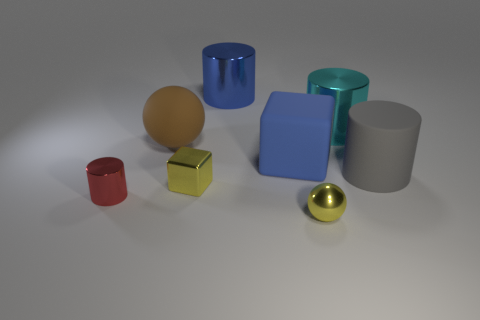There is a large blue thing that is in front of the large cyan object; what is its shape?
Your response must be concise. Cube. What material is the big blue thing that is behind the large cube behind the tiny metal thing that is right of the small yellow block?
Your response must be concise. Metal. How many other things are the same size as the shiny ball?
Keep it short and to the point. 2. What material is the blue thing that is the same shape as the big gray thing?
Offer a very short reply. Metal. What is the color of the small cylinder?
Your response must be concise. Red. What color is the cylinder that is in front of the large object that is in front of the blue rubber cube?
Provide a short and direct response. Red. There is a matte cylinder; is its color the same as the big cylinder that is behind the cyan metal object?
Ensure brevity in your answer.  No. There is a small yellow shiny thing behind the small cylinder behind the small yellow metal ball; what number of big blue objects are in front of it?
Offer a terse response. 0. There is a matte block; are there any metallic spheres left of it?
Keep it short and to the point. No. Is there anything else that has the same color as the rubber sphere?
Offer a terse response. No. 